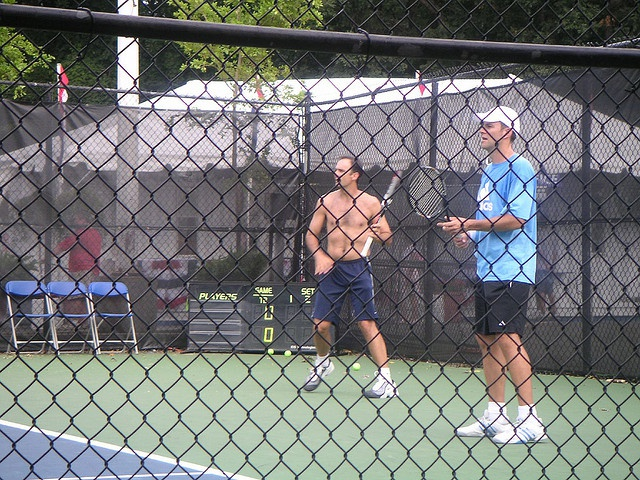Describe the objects in this image and their specific colors. I can see people in black, white, lightblue, and gray tones, people in black, lightpink, gray, navy, and lightgray tones, chair in black, gray, and darkgray tones, chair in black, gray, and darkgray tones, and chair in black, gray, and lightblue tones in this image. 